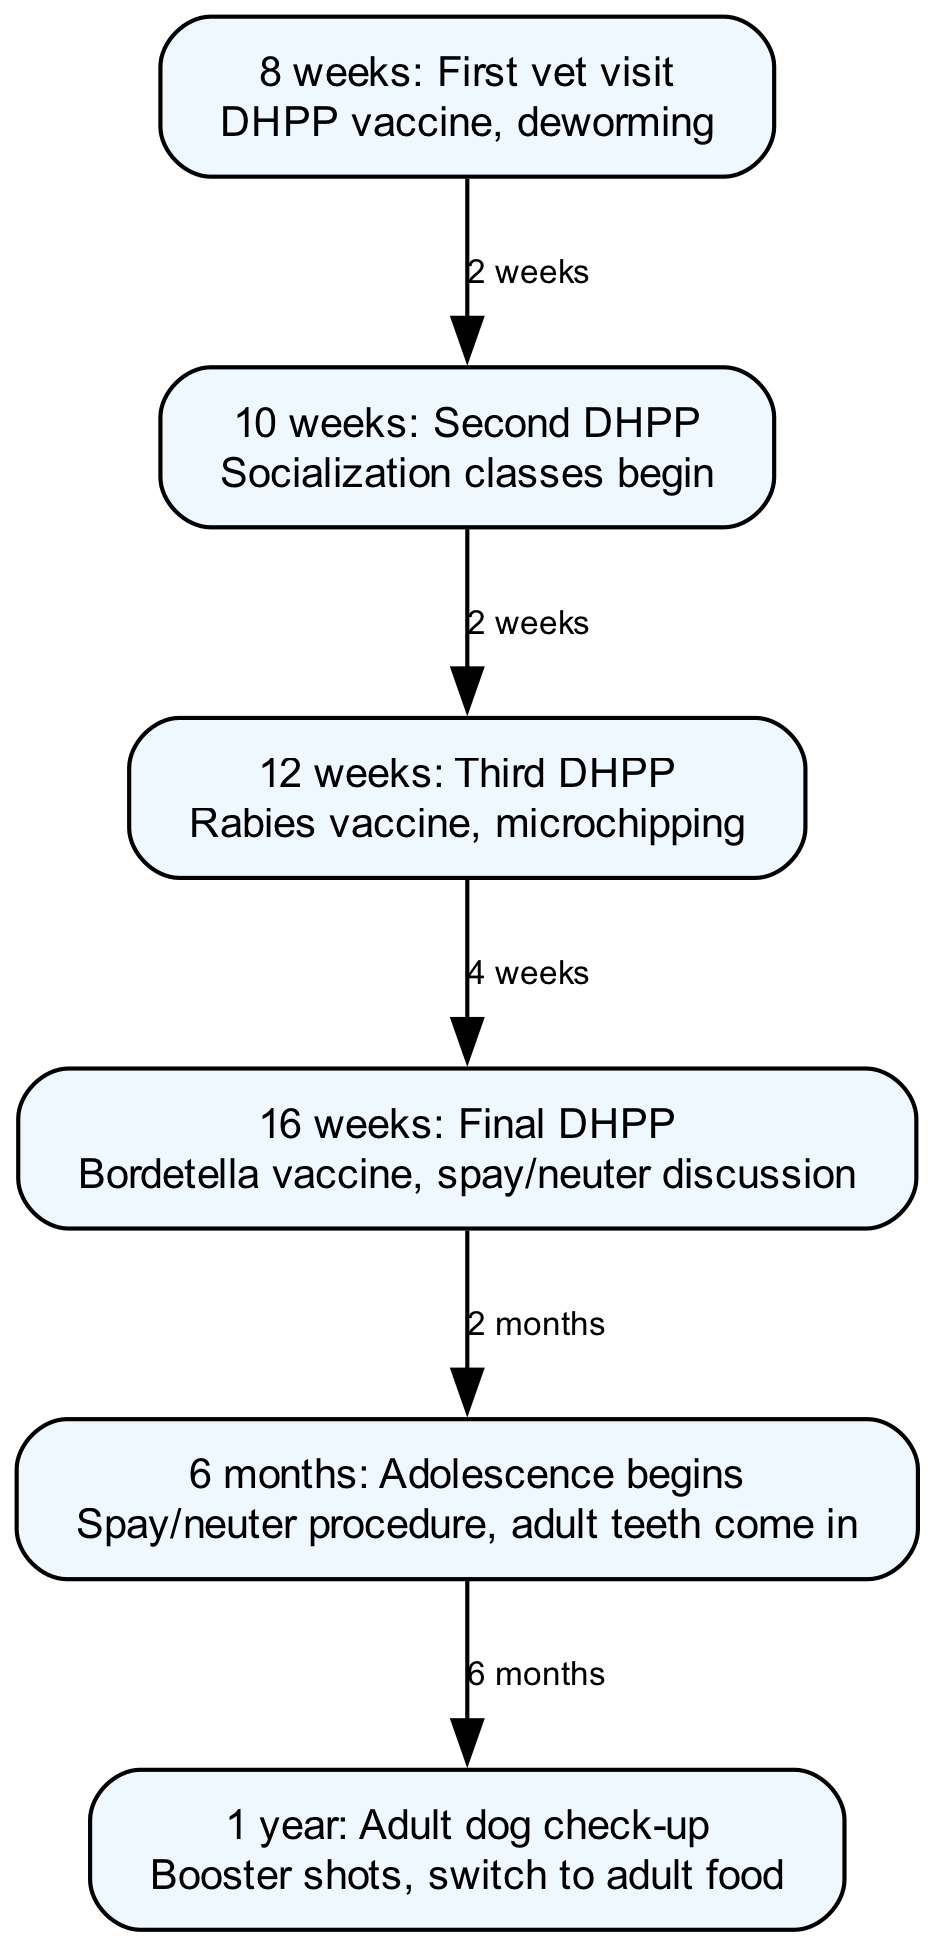What is the first vet visit? The first vet visit occurs at 8 weeks of age and includes the DHPP vaccine and deworming.
Answer: 8 weeks: First vet visit How many nodes are in the diagram? The diagram has a total of 6 nodes, each representing a specific stage in the puppy's vaccination schedule and developmental milestones.
Answer: 6 What vaccine is given at 12 weeks? At 12 weeks, the third DHPP vaccine is administered, along with the rabies vaccine and microchipping.
Answer: Third DHPP, rabies What is discussed at 16 weeks? During the visit at 16 weeks, a discussion regarding spaying or neutering the puppy takes place.
Answer: Spay/neuter discussion What happens at 1 year? At 1 year old, the puppy undergoes an adult dog check-up which includes booster shots and switching to adult food.
Answer: Adult dog check-up What is the time interval between the first and second DHPP vaccines? The second DHPP vaccine is given 2 weeks after the first DHPP vaccine at 8 weeks of age.
Answer: 2 weeks How is the puppy's development categorized at 6 months? At 6 months, the puppy enters adolescence, which is identified as a developmental milestone in the diagram.
Answer: Adolescence begins Which vaccine is given last in the series? The final DHPP vaccine is administered at 16 weeks, which is the last in the vaccination series shown in the diagram.
Answer: Final DHPP What milestone occurs between 4 and 6 months? Between 4 and 6 months, the puppy has the spay/neuter procedure and adult teeth come in.
Answer: Spay/neuter procedure, adult teeth come in 